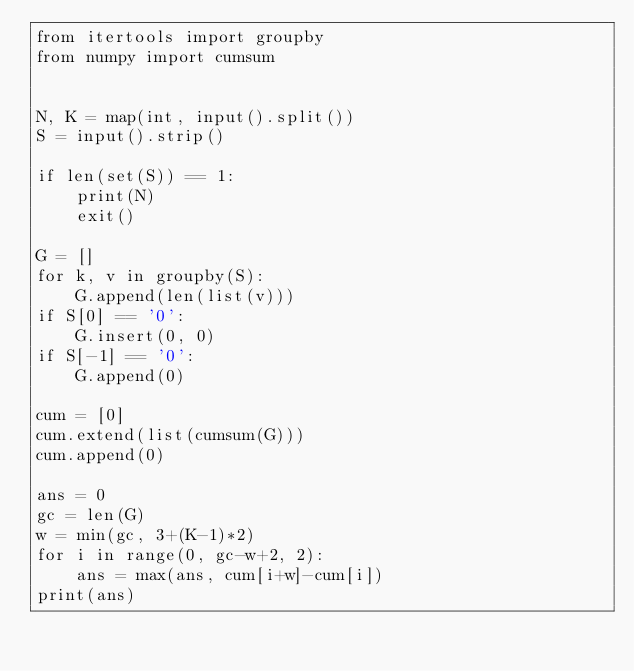Convert code to text. <code><loc_0><loc_0><loc_500><loc_500><_Python_>from itertools import groupby
from numpy import cumsum


N, K = map(int, input().split())
S = input().strip()

if len(set(S)) == 1:
    print(N)
    exit()

G = []
for k, v in groupby(S):
    G.append(len(list(v)))
if S[0] == '0':
    G.insert(0, 0)
if S[-1] == '0':
    G.append(0)

cum = [0]
cum.extend(list(cumsum(G)))
cum.append(0)

ans = 0
gc = len(G)
w = min(gc, 3+(K-1)*2)
for i in range(0, gc-w+2, 2):
    ans = max(ans, cum[i+w]-cum[i])
print(ans)
</code> 